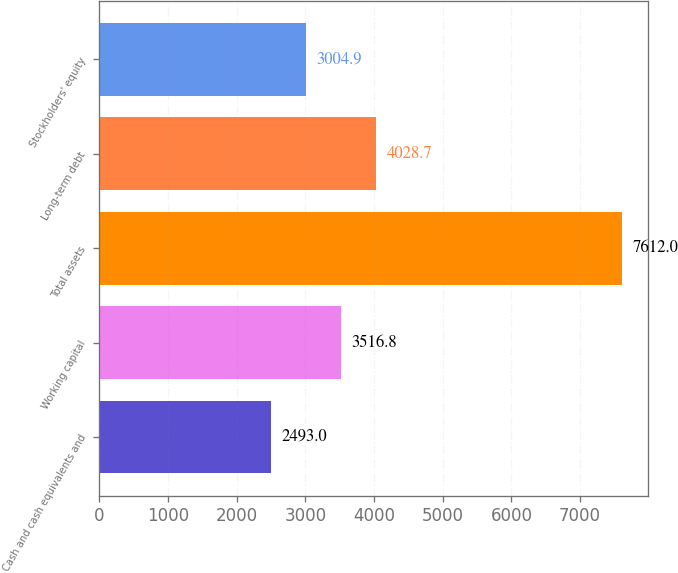Convert chart. <chart><loc_0><loc_0><loc_500><loc_500><bar_chart><fcel>Cash and cash equivalents and<fcel>Working capital<fcel>Total assets<fcel>Long-term debt<fcel>Stockholders' equity<nl><fcel>2493<fcel>3516.8<fcel>7612<fcel>4028.7<fcel>3004.9<nl></chart> 